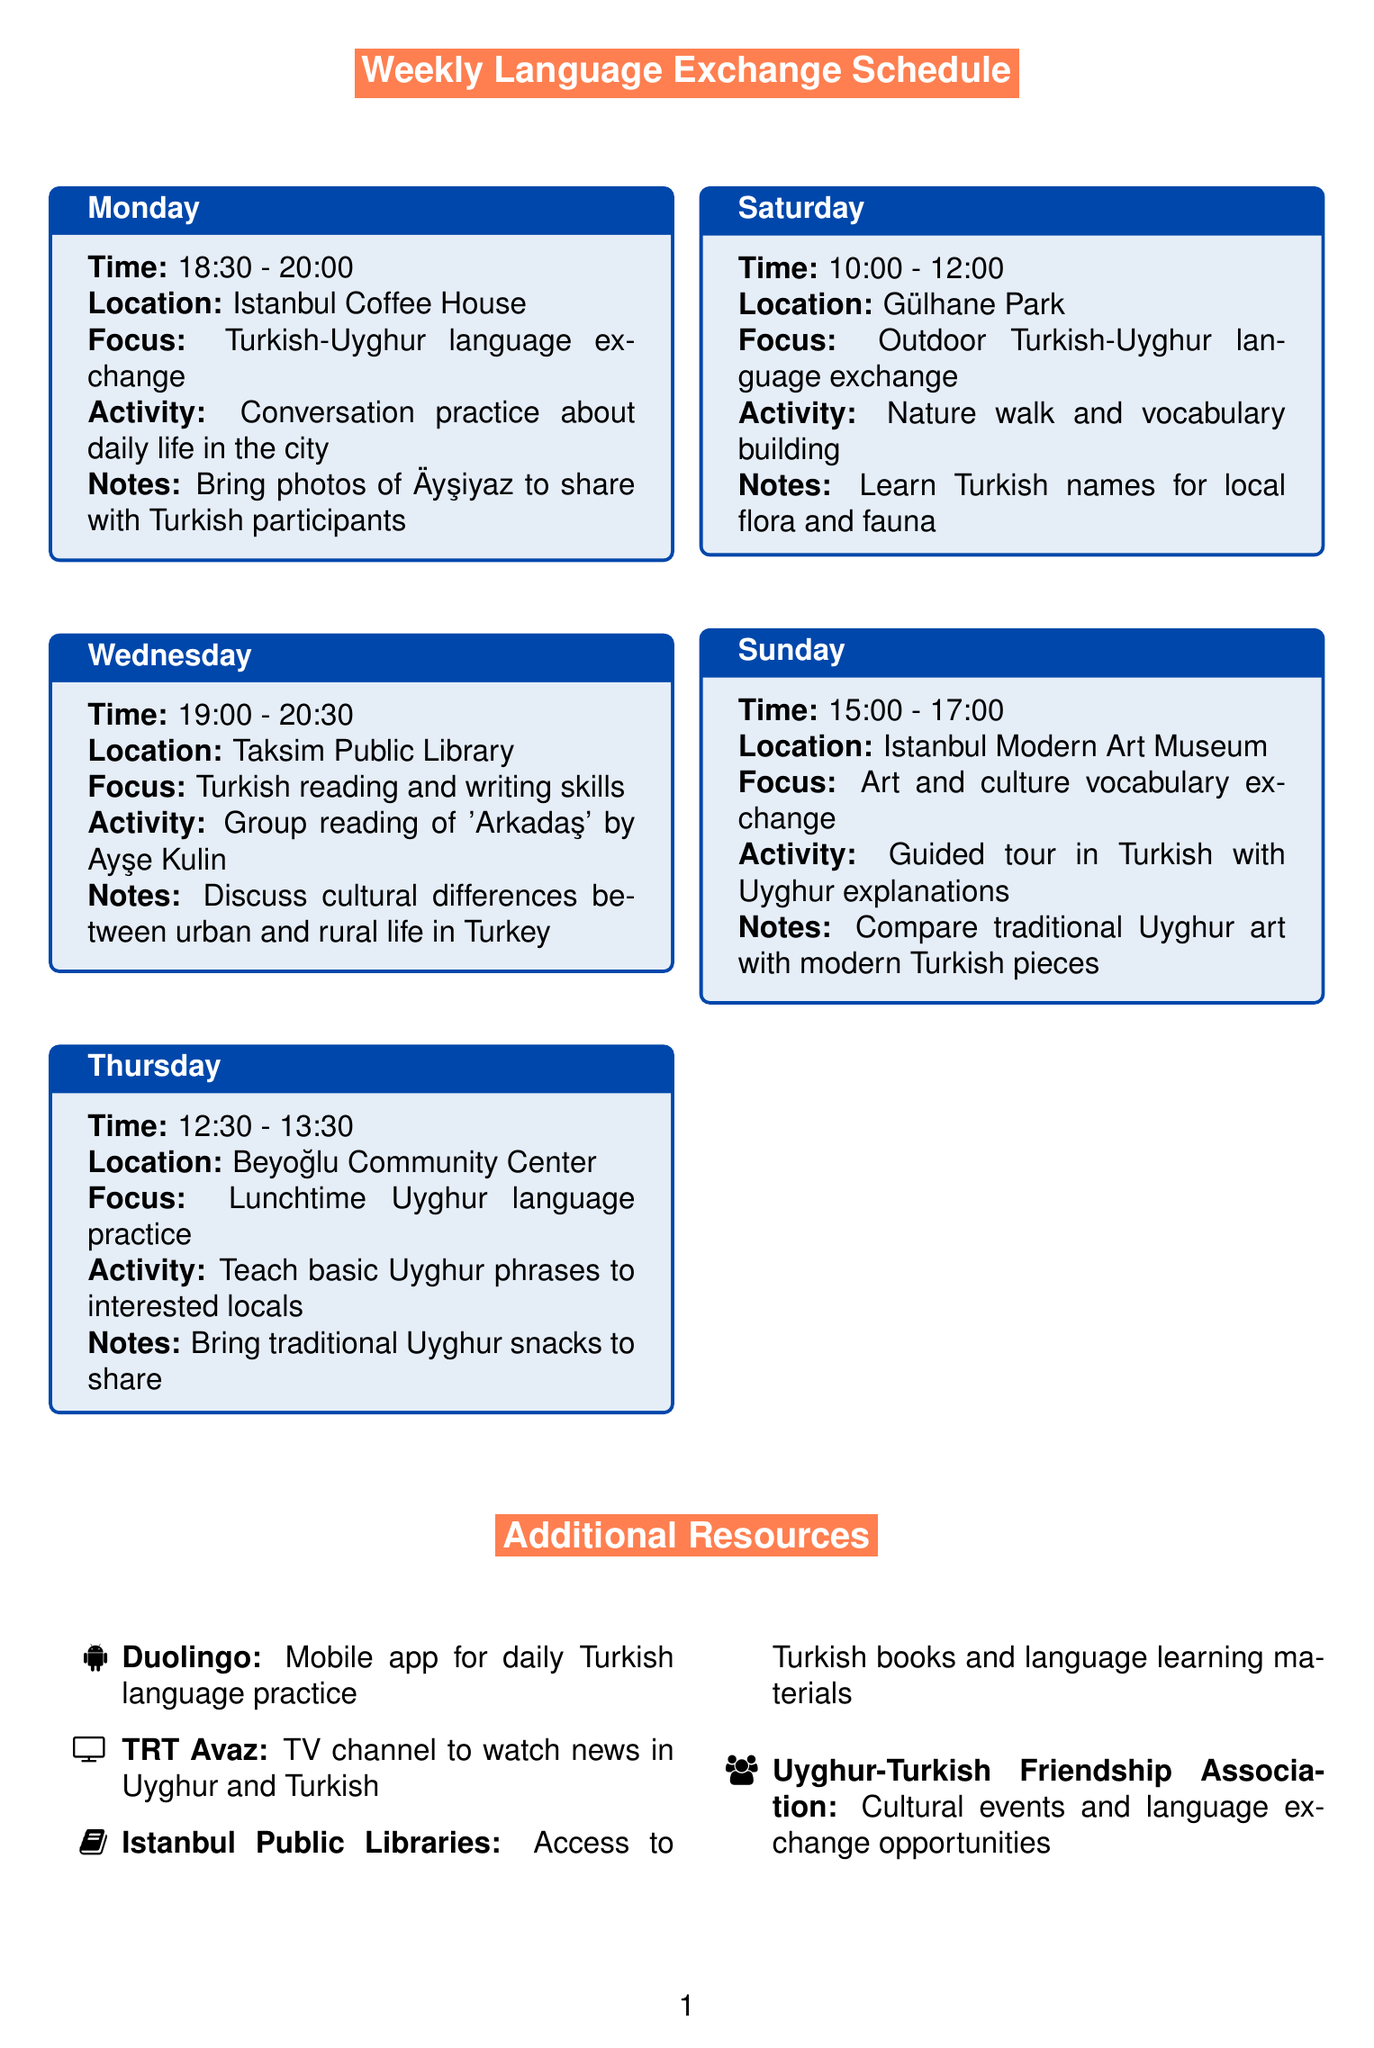What day is the Turkish-Uyghur language exchange? The document states that the Turkish-Uyghur language exchange is on Monday.
Answer: Monday What time does the outdoor language exchange start? The outdoor Turkish-Uyghur language exchange begins at 10:00.
Answer: 10:00 Where is the reading and writing skills session held? The reading and writing skills session is held at Taksim Public Library.
Answer: Taksim Public Library What activity will take place on Sunday at the Istanbul Modern Art Museum? The activity on Sunday is a guided tour in Turkish with Uyghur explanations.
Answer: Guided tour in Turkish with Uyghur explanations How many personal goals are listed in the document? The document lists five personal goals related to language learning and cultural exchange.
Answer: 5 What is the focus of the Thursday lunchtime meeting? The focus of the Thursday lunchtime meeting is on Uyghur language practice.
Answer: Lunchtime Uyghur language practice What additional resource is mentioned for watching news in both languages? TRT Avaz is mentioned as the additional resource for watching news in Uyghur and Turkish.
Answer: TRT Avaz Which community organization is noted for cultural events? The Uyghur-Turkish Friendship Association is noted for cultural events and language exchange opportunities.
Answer: Uyghur-Turkish Friendship Association What should participants bring for the lunch meeting? Participants should bring traditional Uyghur snacks to share during the lunch meeting.
Answer: Traditional Uyghur snacks 